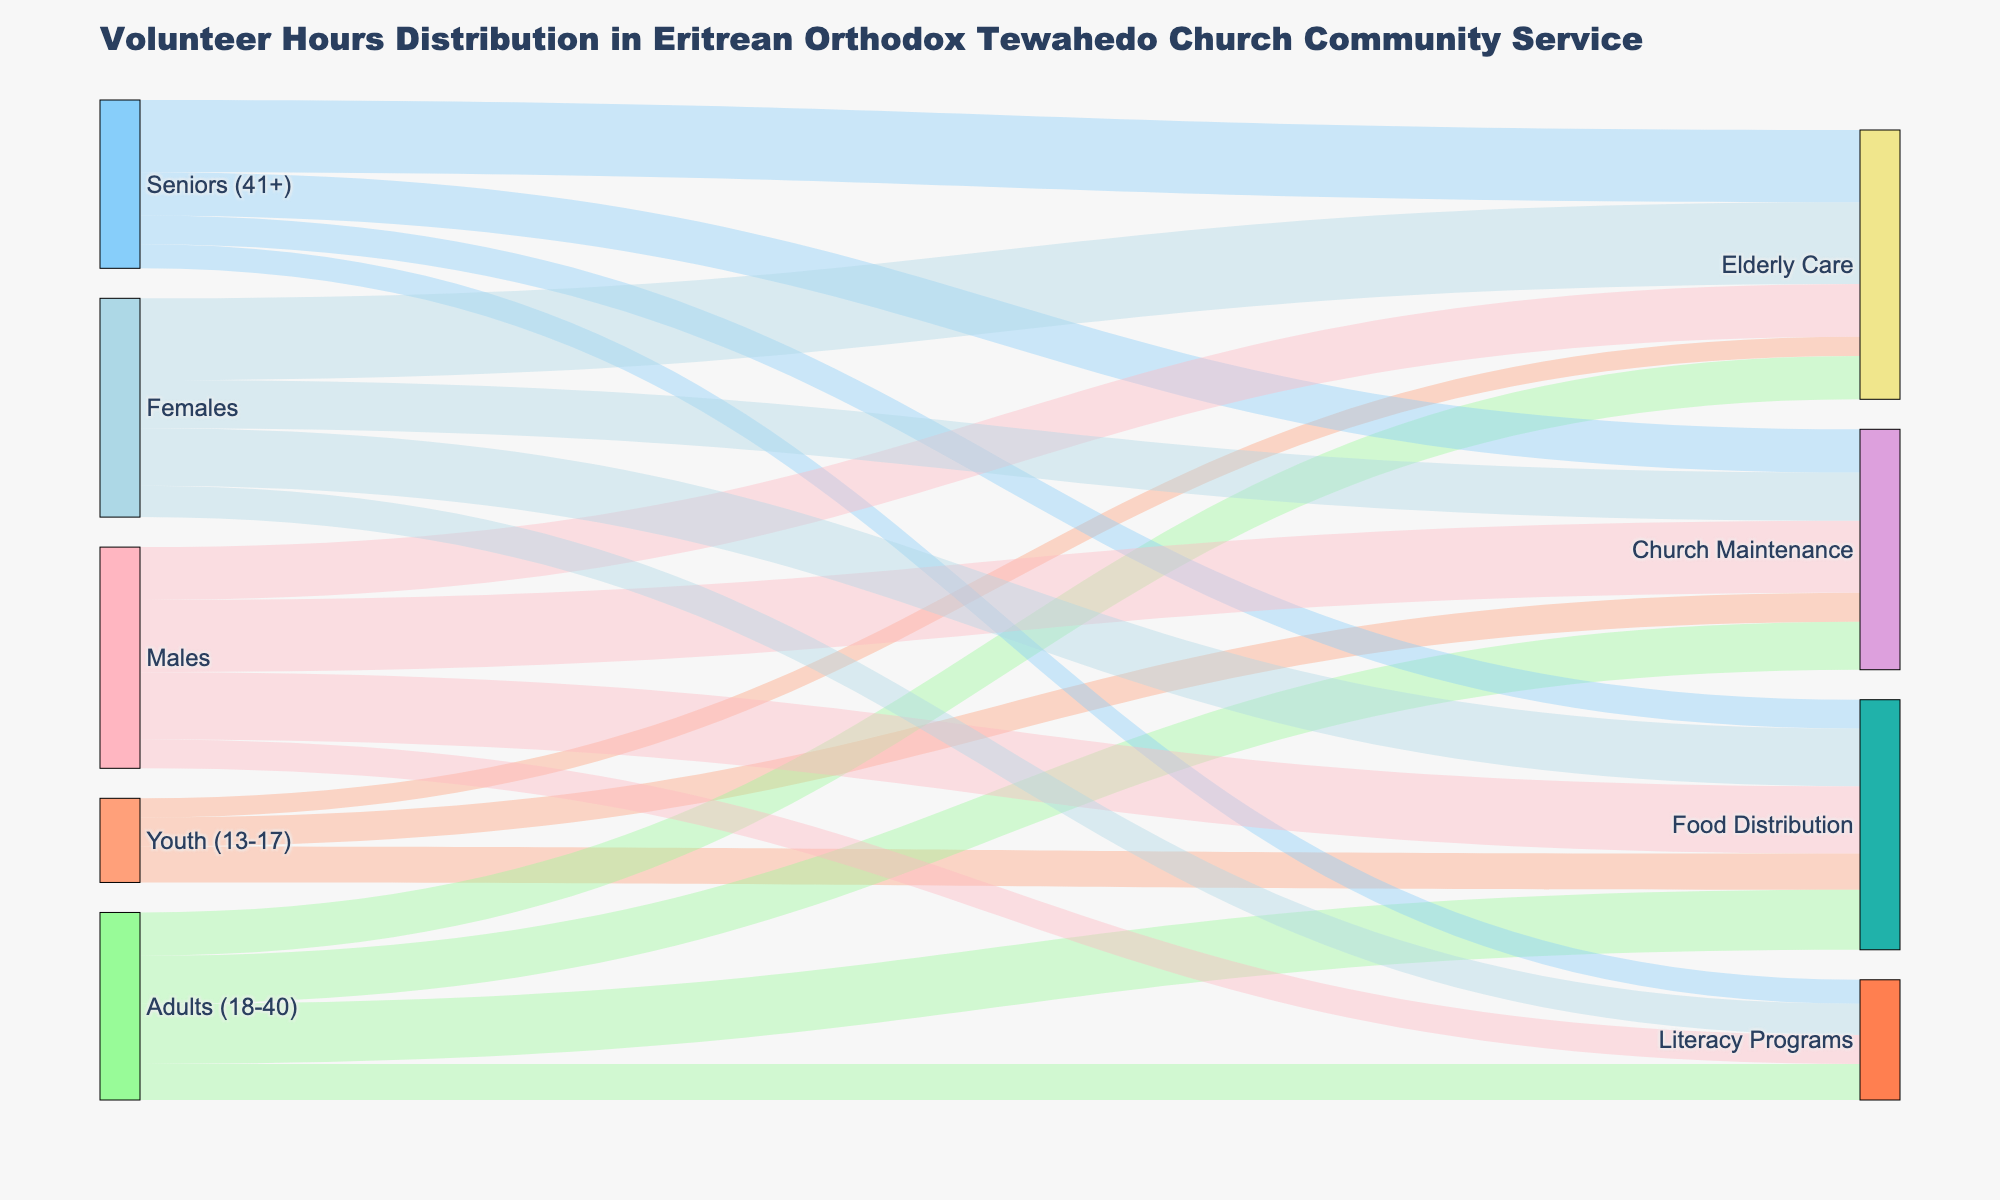What's the title of the figure? The title is usually placed at the top of the figure and provides a brief summary of what the figure represents. In this case, the title is "Volunteer Hours Distribution in Eritrean Orthodox Tewahedo Church Community Service."
Answer: "Volunteer Hours Distribution in Eritrean Orthodox Tewahedo Church Community Service" Which age group contributes the most hours to Food Distribution? To find the age group that contributes the most hours to Food Distribution, look at the links from each age group node to the Food Distribution node and compare their values. The largest value should indicate the greatest contribution. For Food Distribution, the values are 150 (Youth), 250 (Adults), and 120 (Seniors).
Answer: Adults (18-40) How many total volunteer hours do Females contribute across all activities? To find the total volunteer hours contributed by Females, add the hours from Females to each activity: Church Maintenance (200), Elderly Care (340), Food Distribution (240), Literacy Programs (130). Sum these values: 200 + 340 + 240 + 130.
Answer: 910 hours Which gender contributes more to Elderly Care? To determine which gender contributes more to Elderly Care, compare the values from Males and Females to Elderly Care. Males contribute 220 hours, and Females contribute 340 hours.
Answer: Females What is the combined contribution of Youth (13-17) and Seniors (41+) to Church Maintenance? Add the contributions of Youth (13-17) and Seniors (41+) to Church Maintenance. Youth contribute 120 hours, and Seniors contribute 180 hours. Add these values: 120 + 180.
Answer: 300 hours Do Adults (18-40) contribute more hours to Literacy Programs than Seniors (41+)? To find out, compare the contributions from Adults and Seniors to Literacy Programs. Adults contribute 150 hours, and Seniors contribute 100 hours. Since 150 is greater than 100, Adults contribute more.
Answer: Yes Which activity has the least amount of volunteer hours from the Youth (13-17) group? Compare the hours Youth (13-17) contribute to each activity: Church Maintenance (120), Elderly Care (80), Food Distribution (150). The smallest value is 80 for Elderly Care.
Answer: Elderly Care What are the total volunteer hours for Church Maintenance across all groups? Sum the contributions to Church Maintenance from all groups: Youth (120), Adults (200), Seniors (180), Males (300), Females (200). Sum these values: 120 + 200 + 180 + 300 + 200.
Answer: 1000 hours Which activity receives more hours from Males compared to Females? Compare the contributions of Males and Females to each activity: Church Maintenance (300 vs 200), Elderly Care (220 vs 340), Food Distribution (280 vs 240), Literacy Programs (120 vs 130). Church Maintenance and Food Distribution have more hours from Males than Females.
Answer: Church Maintenance and Food Distribution 